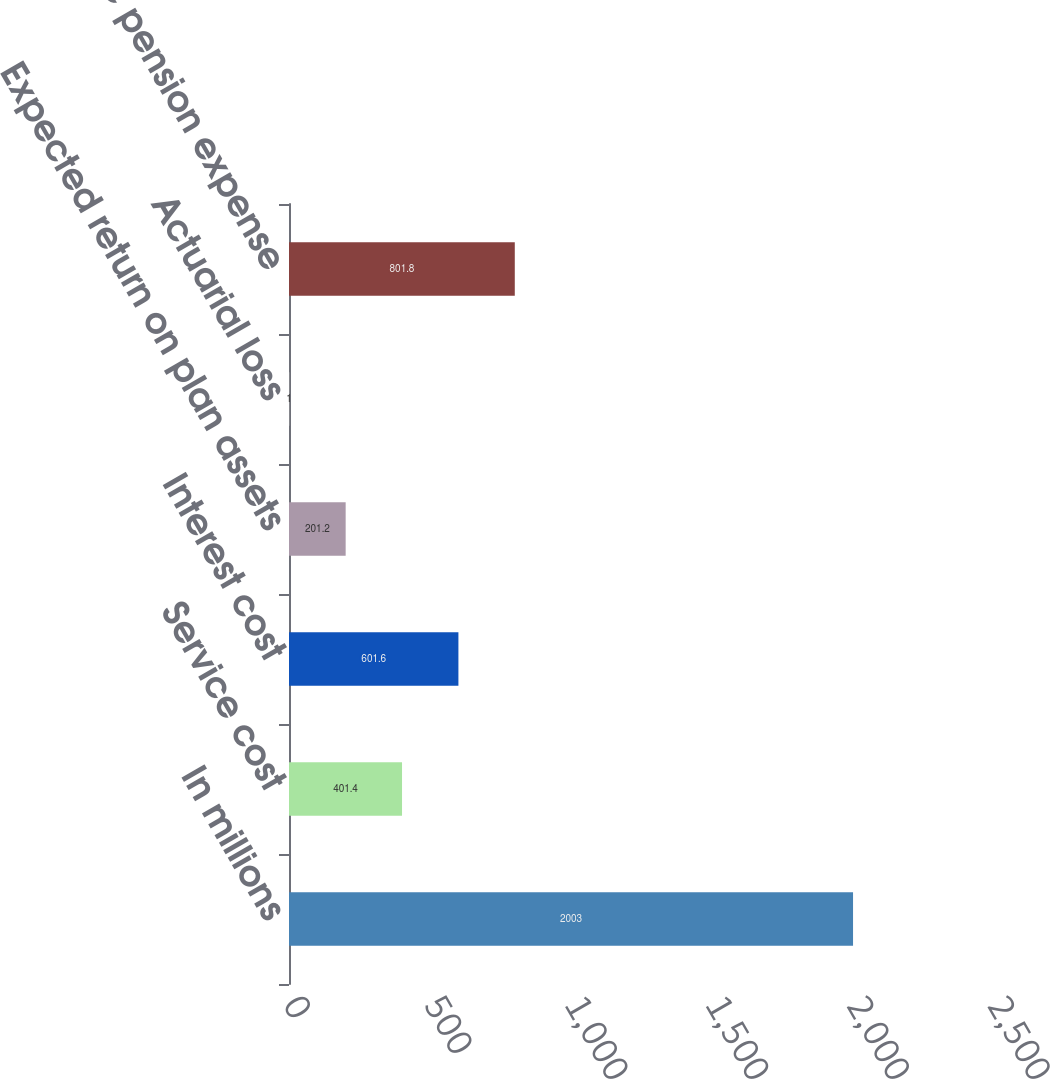<chart> <loc_0><loc_0><loc_500><loc_500><bar_chart><fcel>In millions<fcel>Service cost<fcel>Interest cost<fcel>Expected return on plan assets<fcel>Actuarial loss<fcel>Net periodic pension expense<nl><fcel>2003<fcel>401.4<fcel>601.6<fcel>201.2<fcel>1<fcel>801.8<nl></chart> 